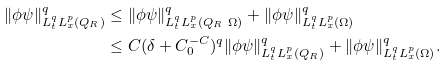<formula> <loc_0><loc_0><loc_500><loc_500>\| \phi \psi \| ^ { q } _ { L ^ { q } _ { t } L ^ { p } _ { x } ( Q _ { R } ) } & \leq \| \phi \psi \| ^ { q } _ { L ^ { q } _ { t } L ^ { p } _ { x } ( Q _ { R } \ \Omega ) } + \| \phi \psi \| ^ { q } _ { L ^ { q } _ { t } L ^ { p } _ { x } ( \Omega ) } \\ & \leq C ( \delta + C _ { 0 } ^ { - C } ) ^ { q } \| \phi \psi \| ^ { q } _ { L ^ { q } _ { t } L ^ { p } _ { x } ( Q _ { R } ) } + \| \phi \psi \| ^ { q } _ { L ^ { q } _ { t } L ^ { p } _ { x } ( \Omega ) } .</formula> 